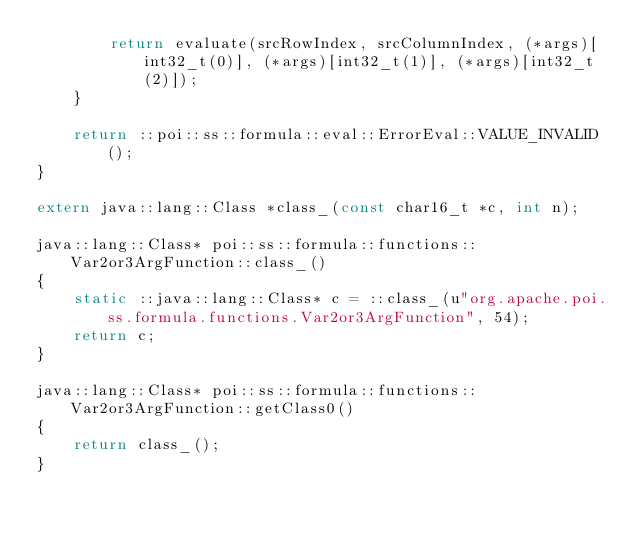Convert code to text. <code><loc_0><loc_0><loc_500><loc_500><_C++_>        return evaluate(srcRowIndex, srcColumnIndex, (*args)[int32_t(0)], (*args)[int32_t(1)], (*args)[int32_t(2)]);
    }

    return ::poi::ss::formula::eval::ErrorEval::VALUE_INVALID();
}

extern java::lang::Class *class_(const char16_t *c, int n);

java::lang::Class* poi::ss::formula::functions::Var2or3ArgFunction::class_()
{
    static ::java::lang::Class* c = ::class_(u"org.apache.poi.ss.formula.functions.Var2or3ArgFunction", 54);
    return c;
}

java::lang::Class* poi::ss::formula::functions::Var2or3ArgFunction::getClass0()
{
    return class_();
}

</code> 